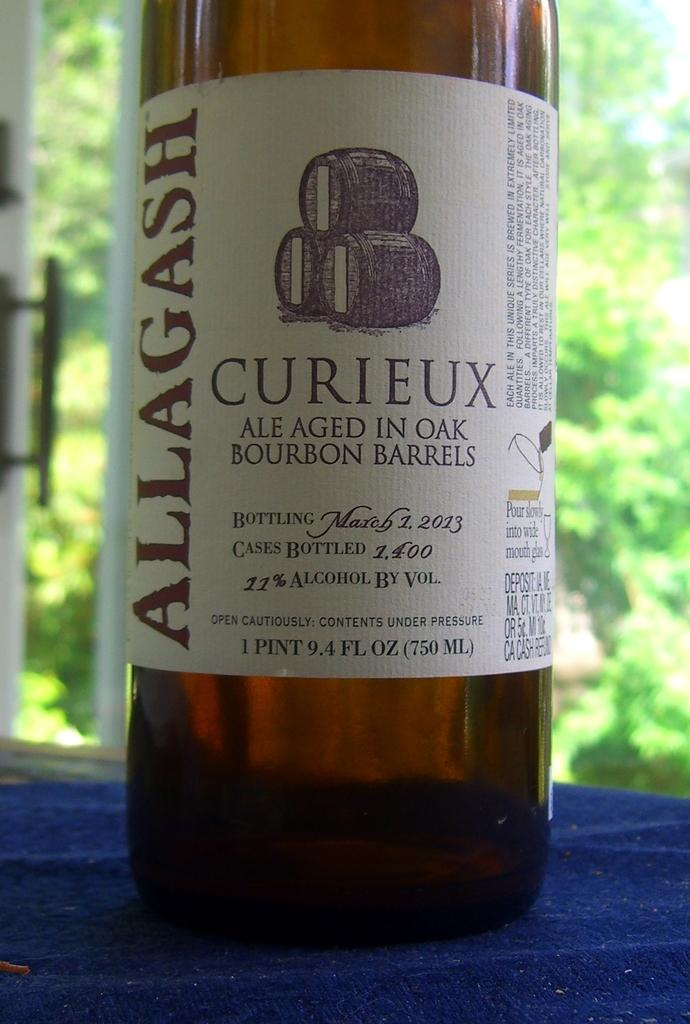What is the main object in the image? There is a wine bottle in the image. What can be seen on the wine bottle? The wine bottle has a sticker on it. What is the wine bottle placed on? The wine bottle is on a blue platform. What can be seen in the background of the image? There is a door and trees in the background of the image. What type of cave is visible in the image? There is no cave present in the image; it features a wine bottle on a blue platform with a door and trees in the background. 